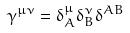<formula> <loc_0><loc_0><loc_500><loc_500>\gamma ^ { \mu \nu } = \delta _ { A } ^ { \mu } \delta _ { B } ^ { \nu } \delta ^ { A B }</formula> 